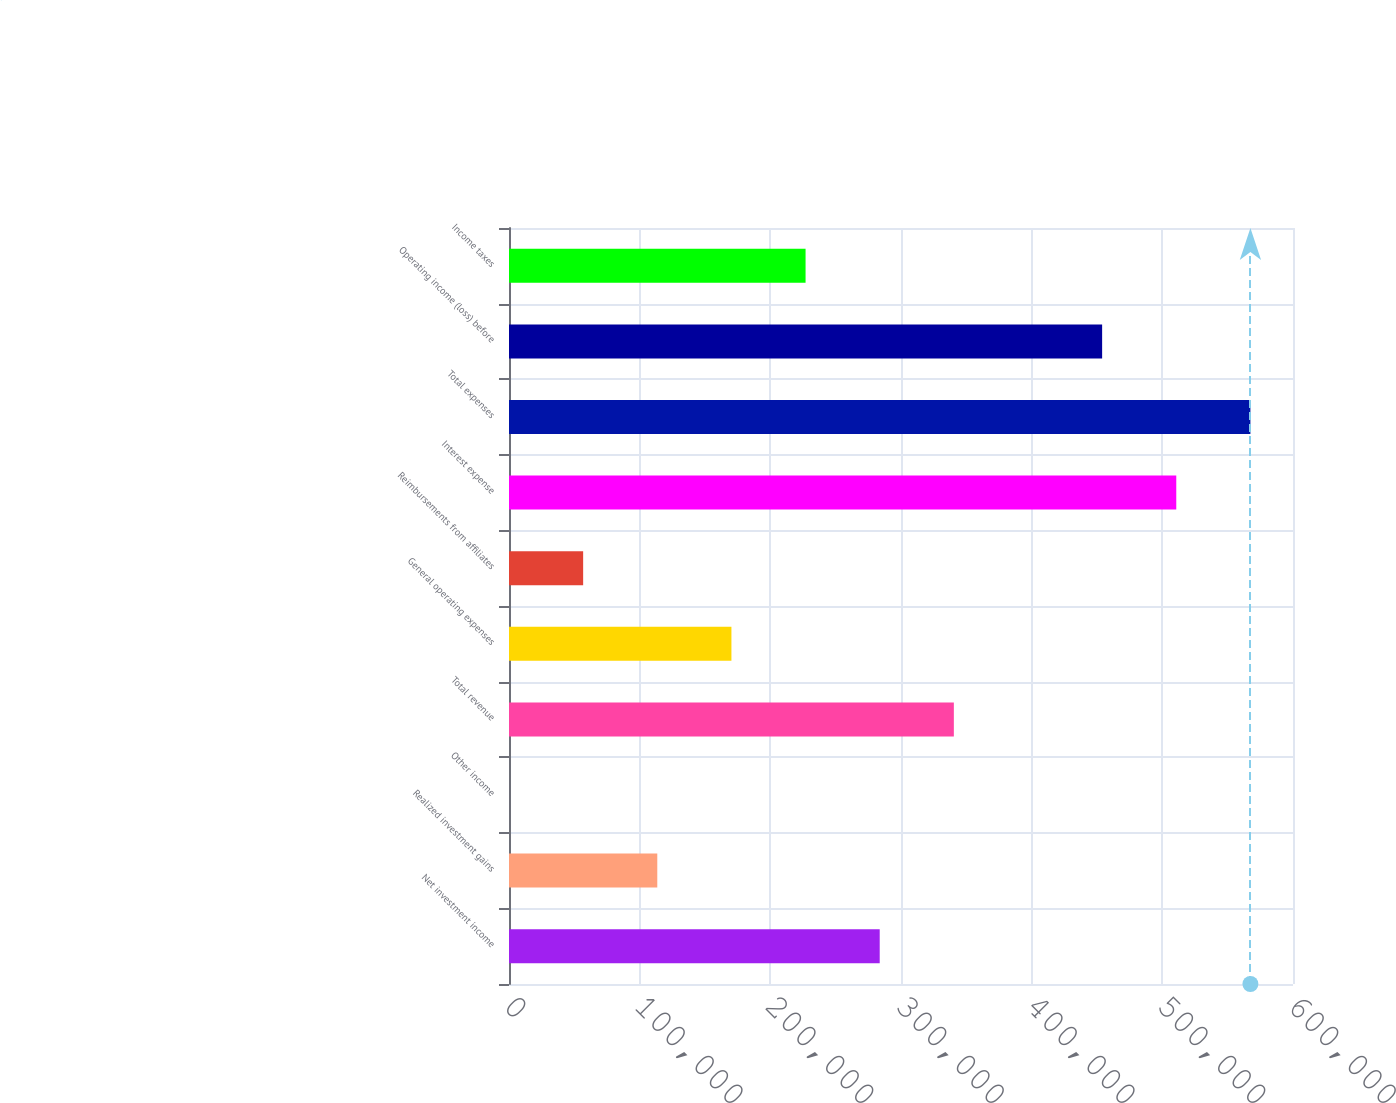Convert chart. <chart><loc_0><loc_0><loc_500><loc_500><bar_chart><fcel>Net investment income<fcel>Realized investment gains<fcel>Other income<fcel>Total revenue<fcel>General operating expenses<fcel>Reimbursements from affiliates<fcel>Interest expense<fcel>Total expenses<fcel>Operating income (loss) before<fcel>Income taxes<nl><fcel>283706<fcel>113485<fcel>4.04<fcel>340446<fcel>170225<fcel>56744.4<fcel>510668<fcel>567408<fcel>453927<fcel>226966<nl></chart> 